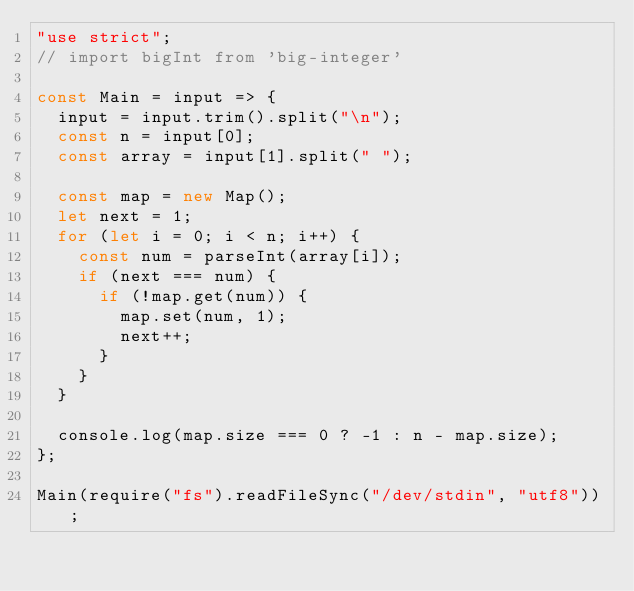Convert code to text. <code><loc_0><loc_0><loc_500><loc_500><_JavaScript_>"use strict";
// import bigInt from 'big-integer'

const Main = input => {
  input = input.trim().split("\n");
  const n = input[0];
  const array = input[1].split(" ");

  const map = new Map();
  let next = 1;
  for (let i = 0; i < n; i++) {
    const num = parseInt(array[i]);
    if (next === num) {
      if (!map.get(num)) {
        map.set(num, 1);
        next++;
      }
    }
  }

  console.log(map.size === 0 ? -1 : n - map.size);
};

Main(require("fs").readFileSync("/dev/stdin", "utf8"));
</code> 